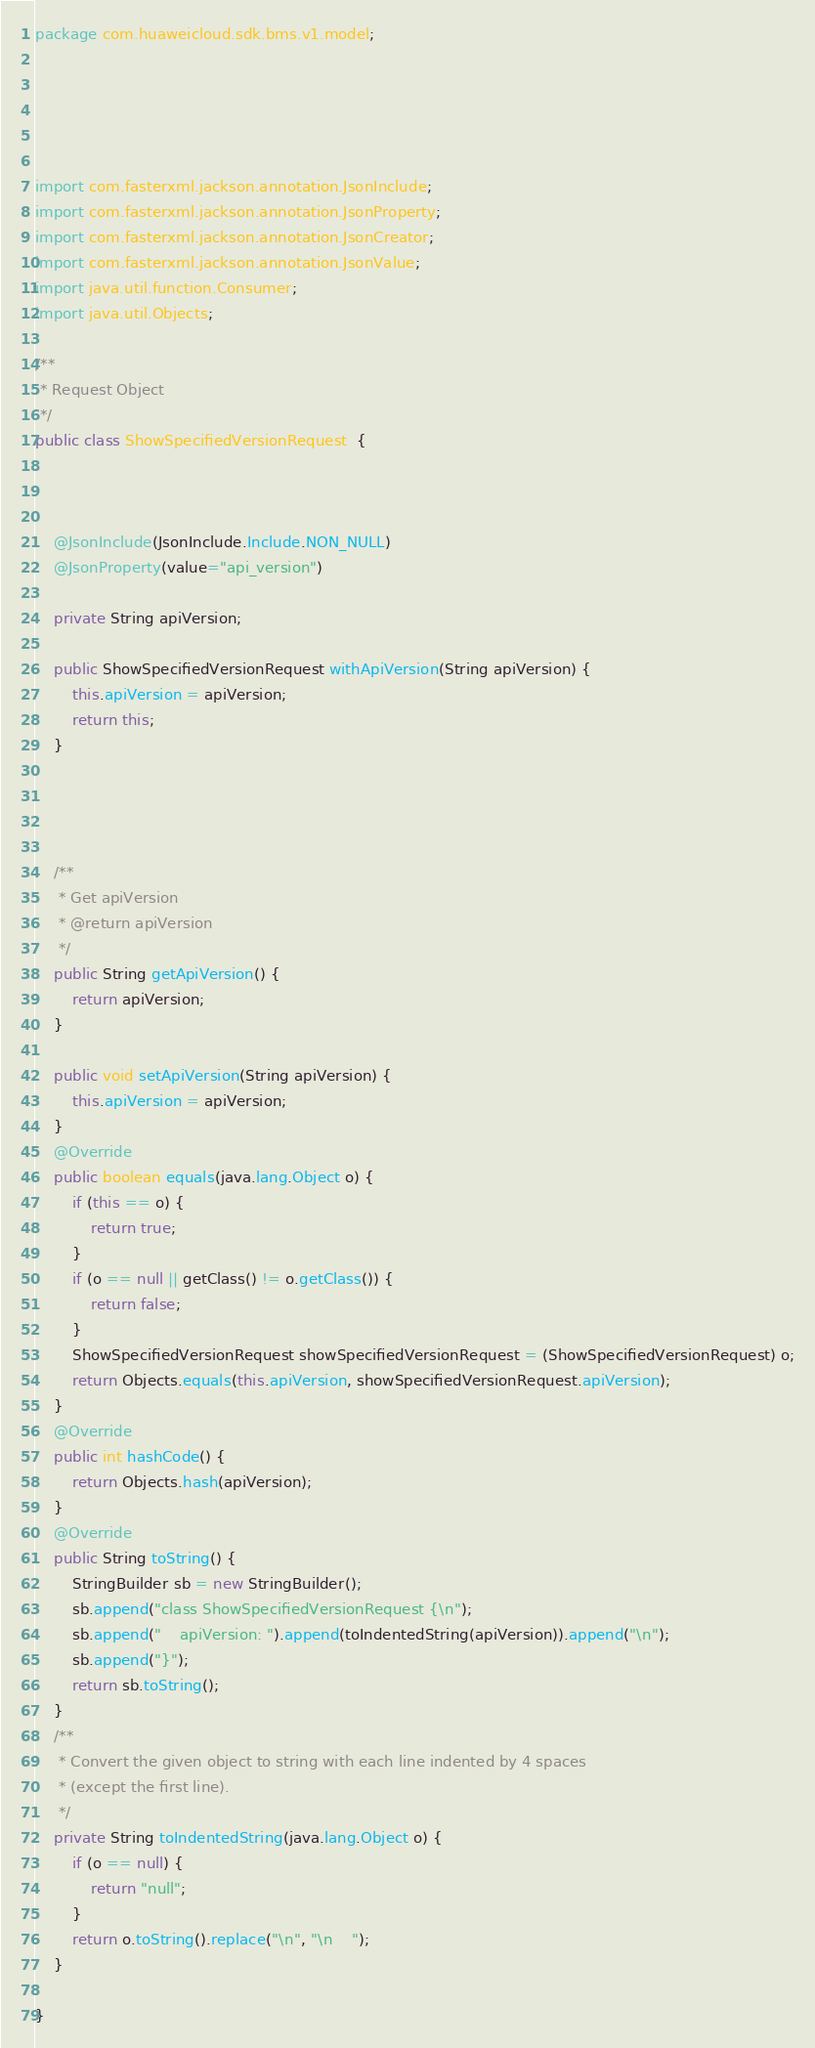Convert code to text. <code><loc_0><loc_0><loc_500><loc_500><_Java_>package com.huaweicloud.sdk.bms.v1.model;





import com.fasterxml.jackson.annotation.JsonInclude;
import com.fasterxml.jackson.annotation.JsonProperty;
import com.fasterxml.jackson.annotation.JsonCreator;
import com.fasterxml.jackson.annotation.JsonValue;
import java.util.function.Consumer;
import java.util.Objects;

/**
 * Request Object
 */
public class ShowSpecifiedVersionRequest  {



    @JsonInclude(JsonInclude.Include.NON_NULL)
    @JsonProperty(value="api_version")
    
    private String apiVersion;

    public ShowSpecifiedVersionRequest withApiVersion(String apiVersion) {
        this.apiVersion = apiVersion;
        return this;
    }

    


    /**
     * Get apiVersion
     * @return apiVersion
     */
    public String getApiVersion() {
        return apiVersion;
    }

    public void setApiVersion(String apiVersion) {
        this.apiVersion = apiVersion;
    }
    @Override
    public boolean equals(java.lang.Object o) {
        if (this == o) {
            return true;
        }
        if (o == null || getClass() != o.getClass()) {
            return false;
        }
        ShowSpecifiedVersionRequest showSpecifiedVersionRequest = (ShowSpecifiedVersionRequest) o;
        return Objects.equals(this.apiVersion, showSpecifiedVersionRequest.apiVersion);
    }
    @Override
    public int hashCode() {
        return Objects.hash(apiVersion);
    }
    @Override
    public String toString() {
        StringBuilder sb = new StringBuilder();
        sb.append("class ShowSpecifiedVersionRequest {\n");
        sb.append("    apiVersion: ").append(toIndentedString(apiVersion)).append("\n");
        sb.append("}");
        return sb.toString();
    }
    /**
     * Convert the given object to string with each line indented by 4 spaces
     * (except the first line).
     */
    private String toIndentedString(java.lang.Object o) {
        if (o == null) {
            return "null";
        }
        return o.toString().replace("\n", "\n    ");
    }
    
}

</code> 